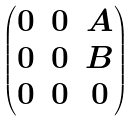<formula> <loc_0><loc_0><loc_500><loc_500>\begin{pmatrix} 0 & 0 & A \\ 0 & 0 & B \\ 0 & 0 & 0 \end{pmatrix}</formula> 